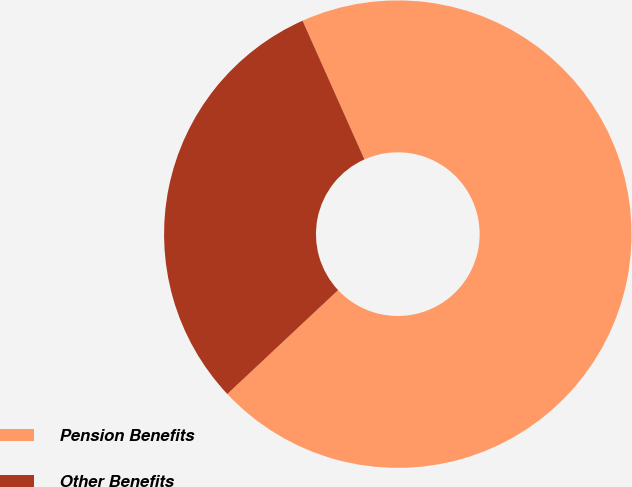Convert chart to OTSL. <chart><loc_0><loc_0><loc_500><loc_500><pie_chart><fcel>Pension Benefits<fcel>Other Benefits<nl><fcel>69.69%<fcel>30.31%<nl></chart> 